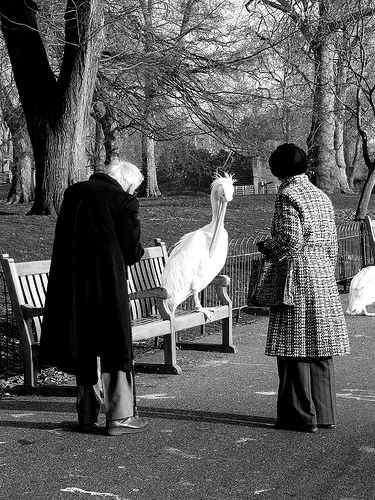What unique features do you notice about the bird? The bird has a significant wingspan and a very long beak. It also has distinct feathers that make it stand out, especially in an urban park setting. Create a dialogue where the bird talks about its daily life in the park. "I spend most of my days perched on this bench or wandering around the tall trees. The humans here are quite friendly and often stop to admire my feathers. Sometimes, they even bring me tasty snacks. The park is my home, and it's always bustling with activity, yet it holds peaceful moments as well. The change of seasons keeps things interesting, and I never get bored watching the leaves change and the weather shift. My favorite time is spring, when the flowers bloom and the park comes alive with color and fragrance." Imagine the park from the bird's perspective as the seasons change. Describe it in detail. From my vantage point, perched on this bench, I witness the park transform through the seasons. In spring, the world awakens with vibrant hues as flowers bloom and the trees dress in lush green leaves. The air is filled with the sweet scent of blossoms and the cheerful songs of other birds. Summer brings warmth and an abundance of visitors, children laughing, families picnicking, and couples walking hand in hand. The park buzzes with energy and life. As autumn arrives, the foliage turns into a canvas of red, orange, and yellow. The gentle rustling of leaves accompanies the cooler breeze, and the park takes on a tranquil aura. Winter wraps the park in a quiet, serene blanket of frost, and occasionally, a delicate snowfall. The visitors become sparse, but the tranquility is unmatched. Each season offers its own beauty, making my life here an ongoing, delightful spectacle. 